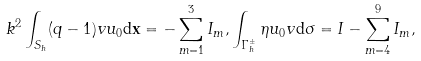<formula> <loc_0><loc_0><loc_500><loc_500>& k ^ { 2 } \int _ { S _ { h } } ( q - 1 ) v u _ { 0 } \mathrm d \mathbf x = - \sum _ { m = 1 } ^ { 3 } I _ { m } , \int _ { \Gamma _ { h } ^ { \pm } } \eta u _ { 0 } v \mathrm d \sigma = I - \sum _ { m = 4 } ^ { 9 } I _ { m } ,</formula> 